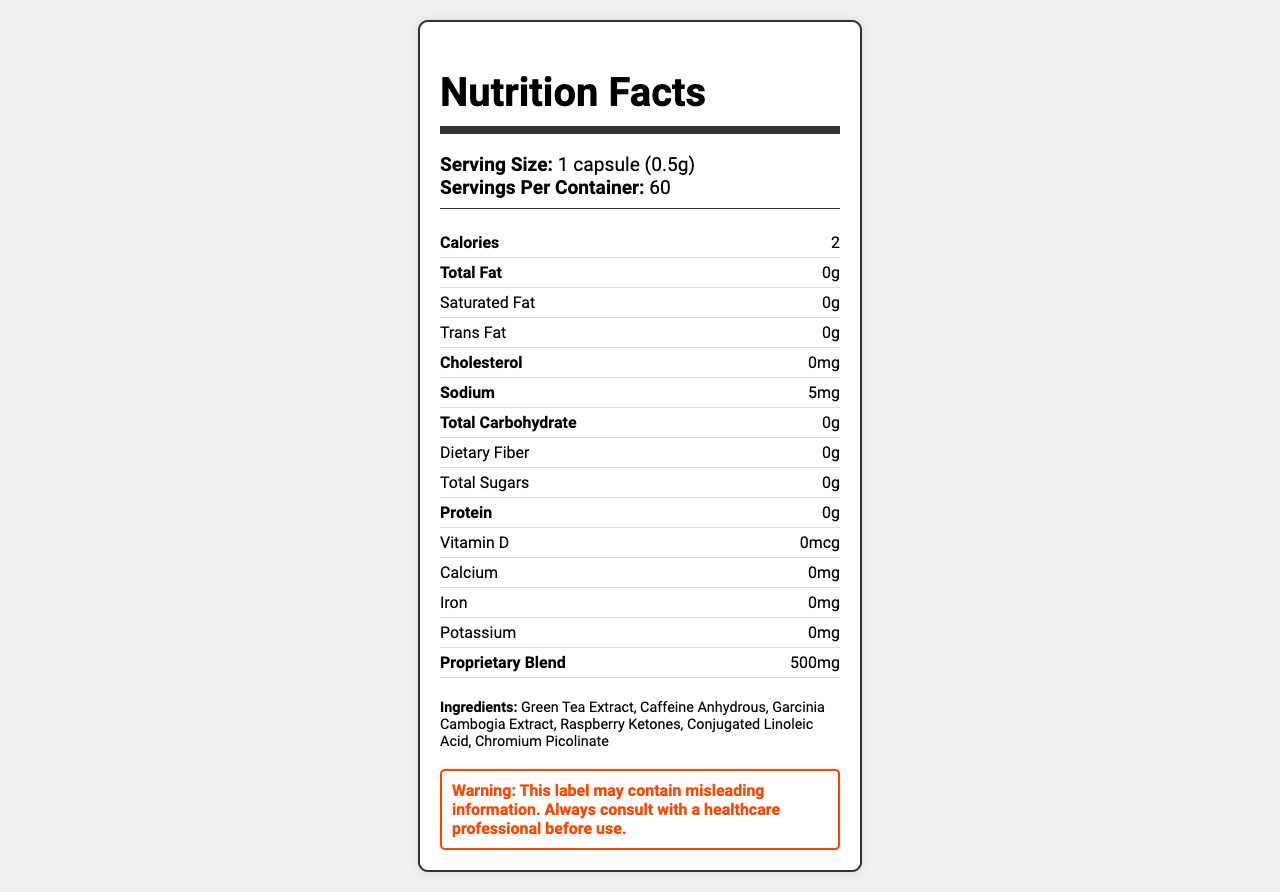what is the serving size of SlimQuick Ultra? The serving size is clearly listed as "1 capsule (0.5g)" in the document.
Answer: 1 capsule (0.5g) how many calories are there per serving? The document specifies that each serving contains 2 calories.
Answer: 2 calories what is the proprietary blend amount in SlimQuick Ultra? The Nutrition Facts label shows "Proprietary Blend: 500mg."
Answer: 500mg which ingredient is NOT listed in the proprietary blend? A. Green Tea Extract B. Green Coffee Bean Extract C. Garcinia Cambogia Extract D. Conjugated Linoleic Acid Green Coffee Bean Extract is not listed in the ingredients, while the others are mentioned.
Answer: B is there any dietary fiber in this product? The document states, "Dietary Fiber: 0g," indicating there is no dietary fiber in the product.
Answer: No what is the total amount of sodium per serving? The Nutrition Facts label shows "Sodium: 5mg" per serving.
Answer: 5mg which one of the following is included in the ingredients list? A. Raspberry Ketones B. MCT Oil C. L-Carnitine D. Ginseng "Raspberry Ketones" is listed among the ingredients.
Answer: A does the product contain any cholesterol? The document specifies "Cholesterol: 0mg," indicating it does not contain cholesterol.
Answer: No how many servings are there per container? The Nutrition Facts label states "Servings Per Container: 60."
Answer: 60 were all ingredients disclosed in the product? The document lists some ingredients but mentions a regulatory violation for "Failure to disclose all ingredients," indicating not all ingredients were disclosed.
Answer: No summarize the main information on the Nutrition Facts label for SlimQuick Ultra. The summary covers the major points of the Nutrition Facts label, including serving size, calorie content, major nutritional information, proprietary blend details, and a warning about potential misleading information.
Answer: SlimQuick Ultra's Nutrition Facts label shows that each serving size is 1 capsule (0.5g), with 2 calories per serving, and it mainly contains 0g of fats, carbohydrates, fibers, and proteins. The label highlights a 500mg proprietary blend and includes ingredients like Green Tea Extract and Caffeine Anhydrous. There are 60 servings per container, and some other nutritional values are provided. The document also raises concerns about potential misleading information. what kind of violation is not mentioned in the document? The document mentions several regulatory violations but does not specify every possible type, so we cannot determine which violation is not mentioned.
Answer: Cannot be determined 